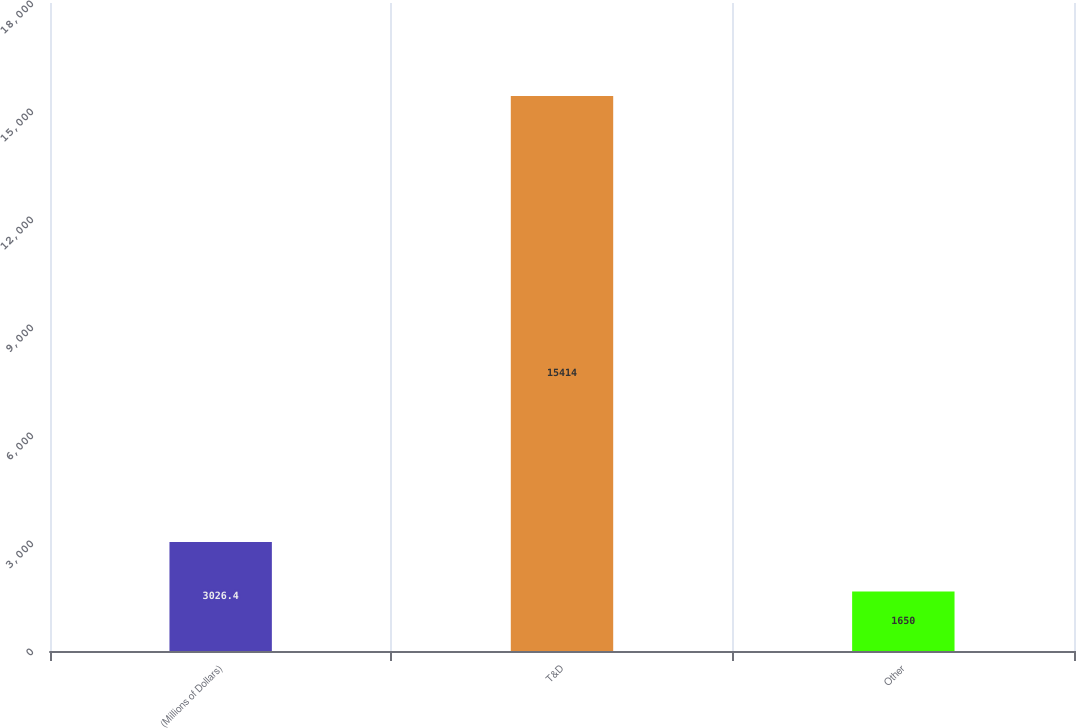Convert chart to OTSL. <chart><loc_0><loc_0><loc_500><loc_500><bar_chart><fcel>(Millions of Dollars)<fcel>T&D<fcel>Other<nl><fcel>3026.4<fcel>15414<fcel>1650<nl></chart> 